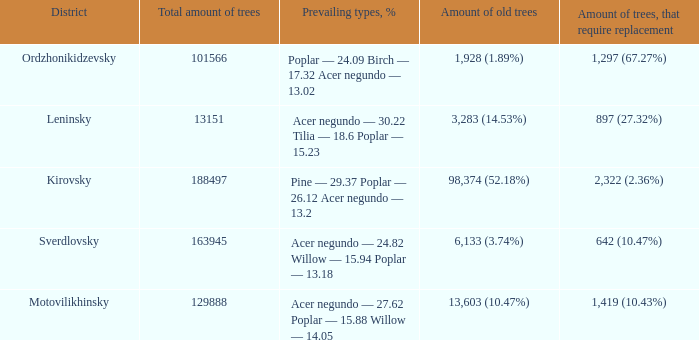What is the district when prevailing types, % is acer negundo — 30.22 tilia — 18.6 poplar — 15.23? Leninsky. 